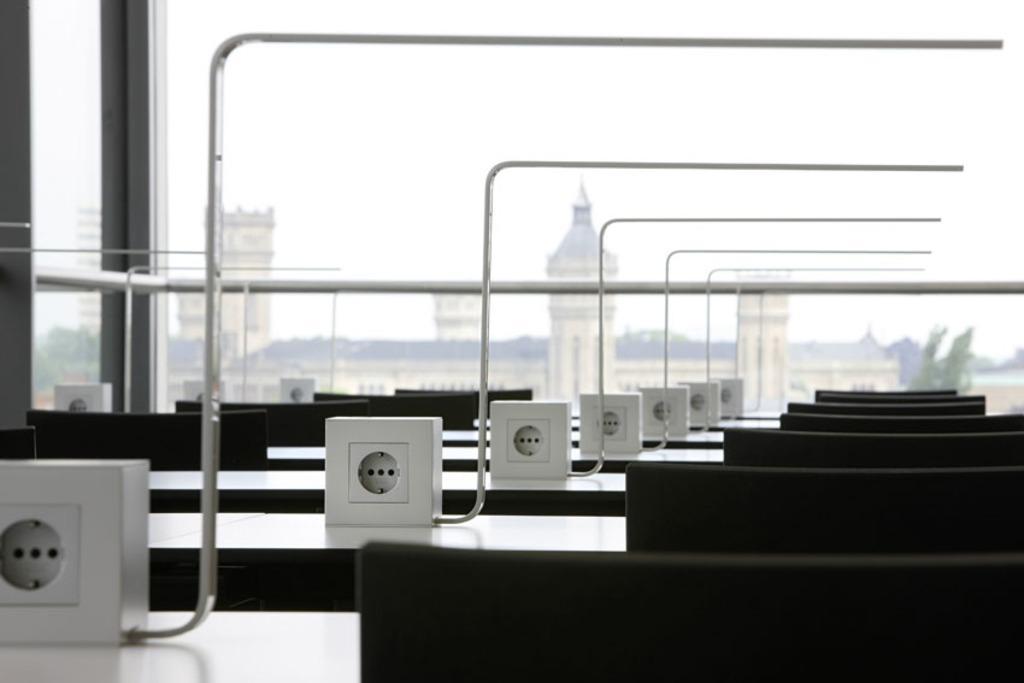Could you give a brief overview of what you see in this image? This picture is clicked outside. In the foreground we can see the metal rods and some black color objects seems to be chairs and we can see the tables and some other objects. In the background there is a sky and we can see the buildings and trees. 